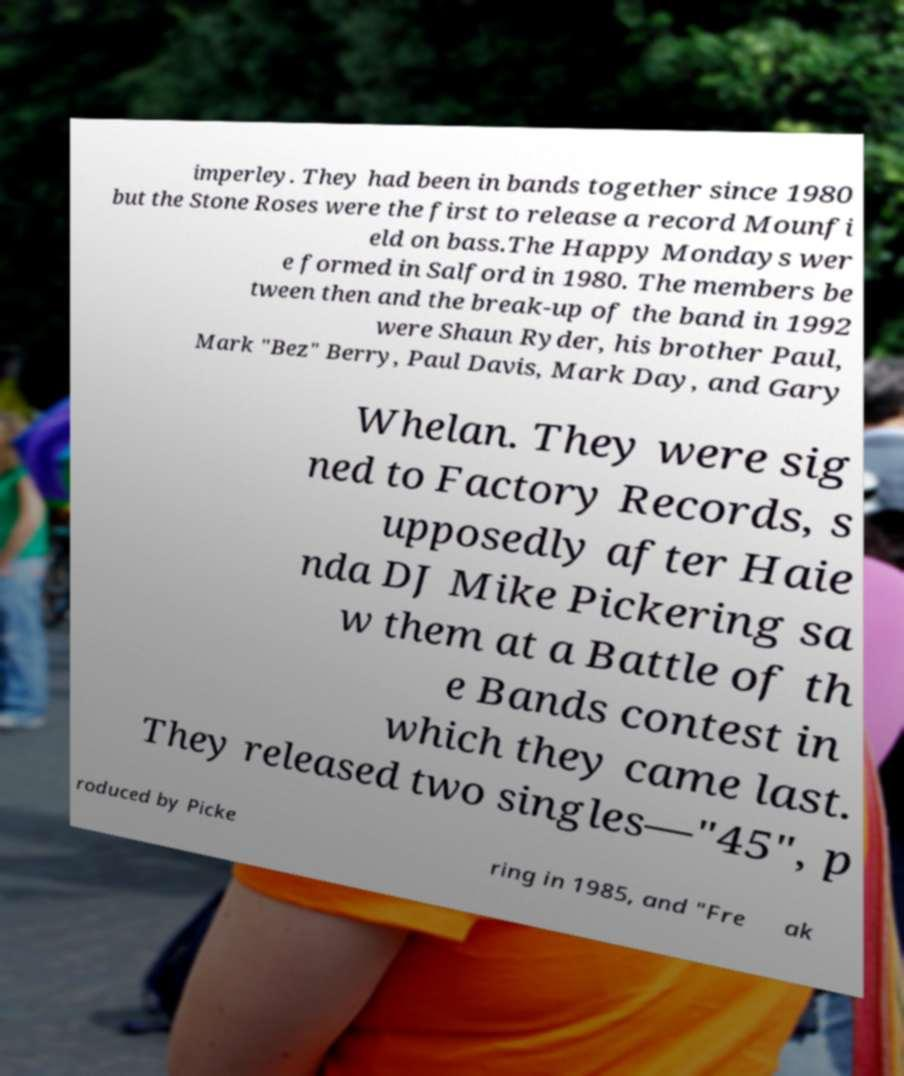Can you accurately transcribe the text from the provided image for me? imperley. They had been in bands together since 1980 but the Stone Roses were the first to release a record Mounfi eld on bass.The Happy Mondays wer e formed in Salford in 1980. The members be tween then and the break-up of the band in 1992 were Shaun Ryder, his brother Paul, Mark "Bez" Berry, Paul Davis, Mark Day, and Gary Whelan. They were sig ned to Factory Records, s upposedly after Haie nda DJ Mike Pickering sa w them at a Battle of th e Bands contest in which they came last. They released two singles—"45", p roduced by Picke ring in 1985, and "Fre ak 